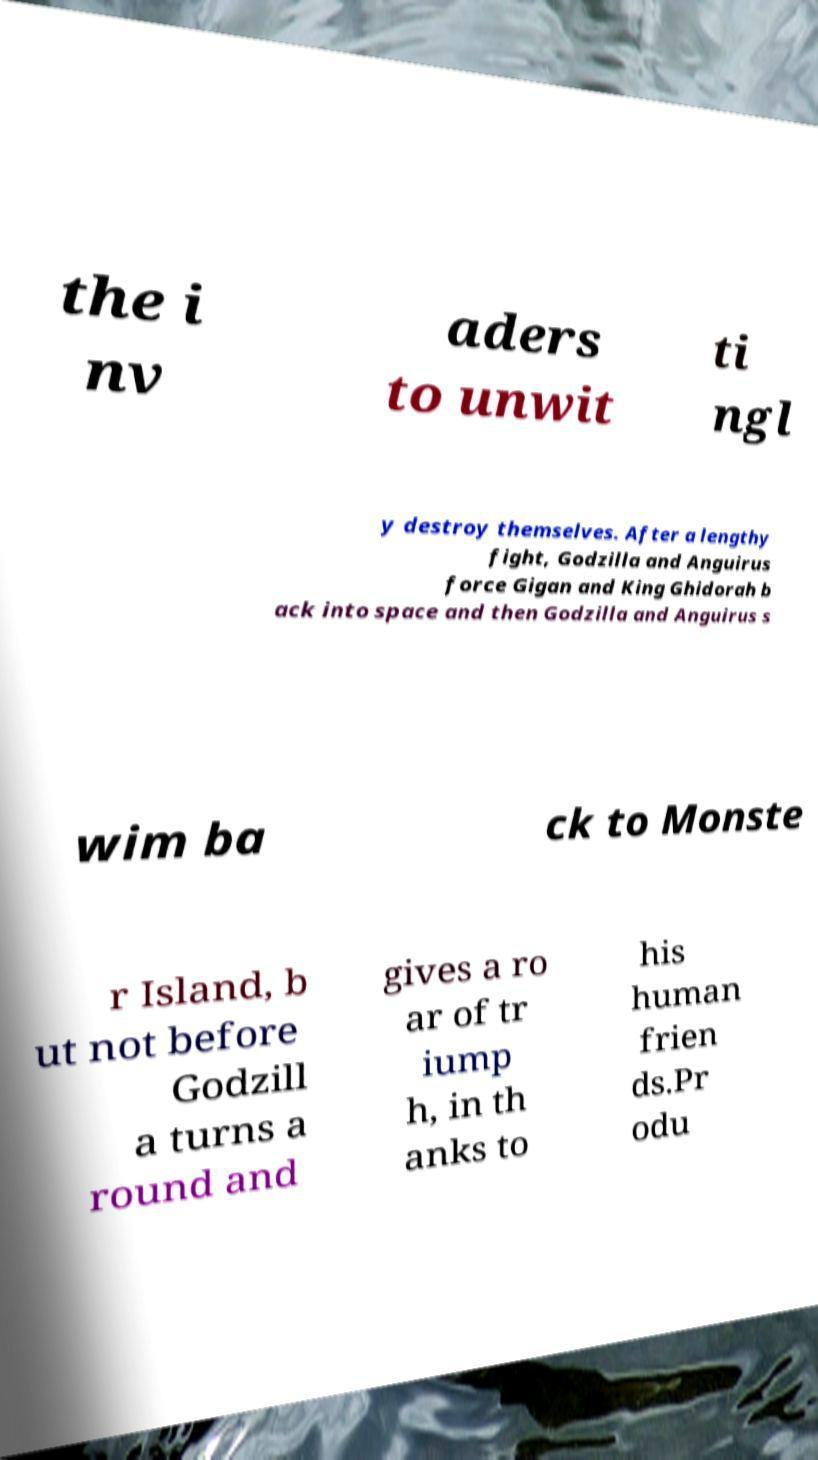Can you read and provide the text displayed in the image?This photo seems to have some interesting text. Can you extract and type it out for me? the i nv aders to unwit ti ngl y destroy themselves. After a lengthy fight, Godzilla and Anguirus force Gigan and King Ghidorah b ack into space and then Godzilla and Anguirus s wim ba ck to Monste r Island, b ut not before Godzill a turns a round and gives a ro ar of tr iump h, in th anks to his human frien ds.Pr odu 